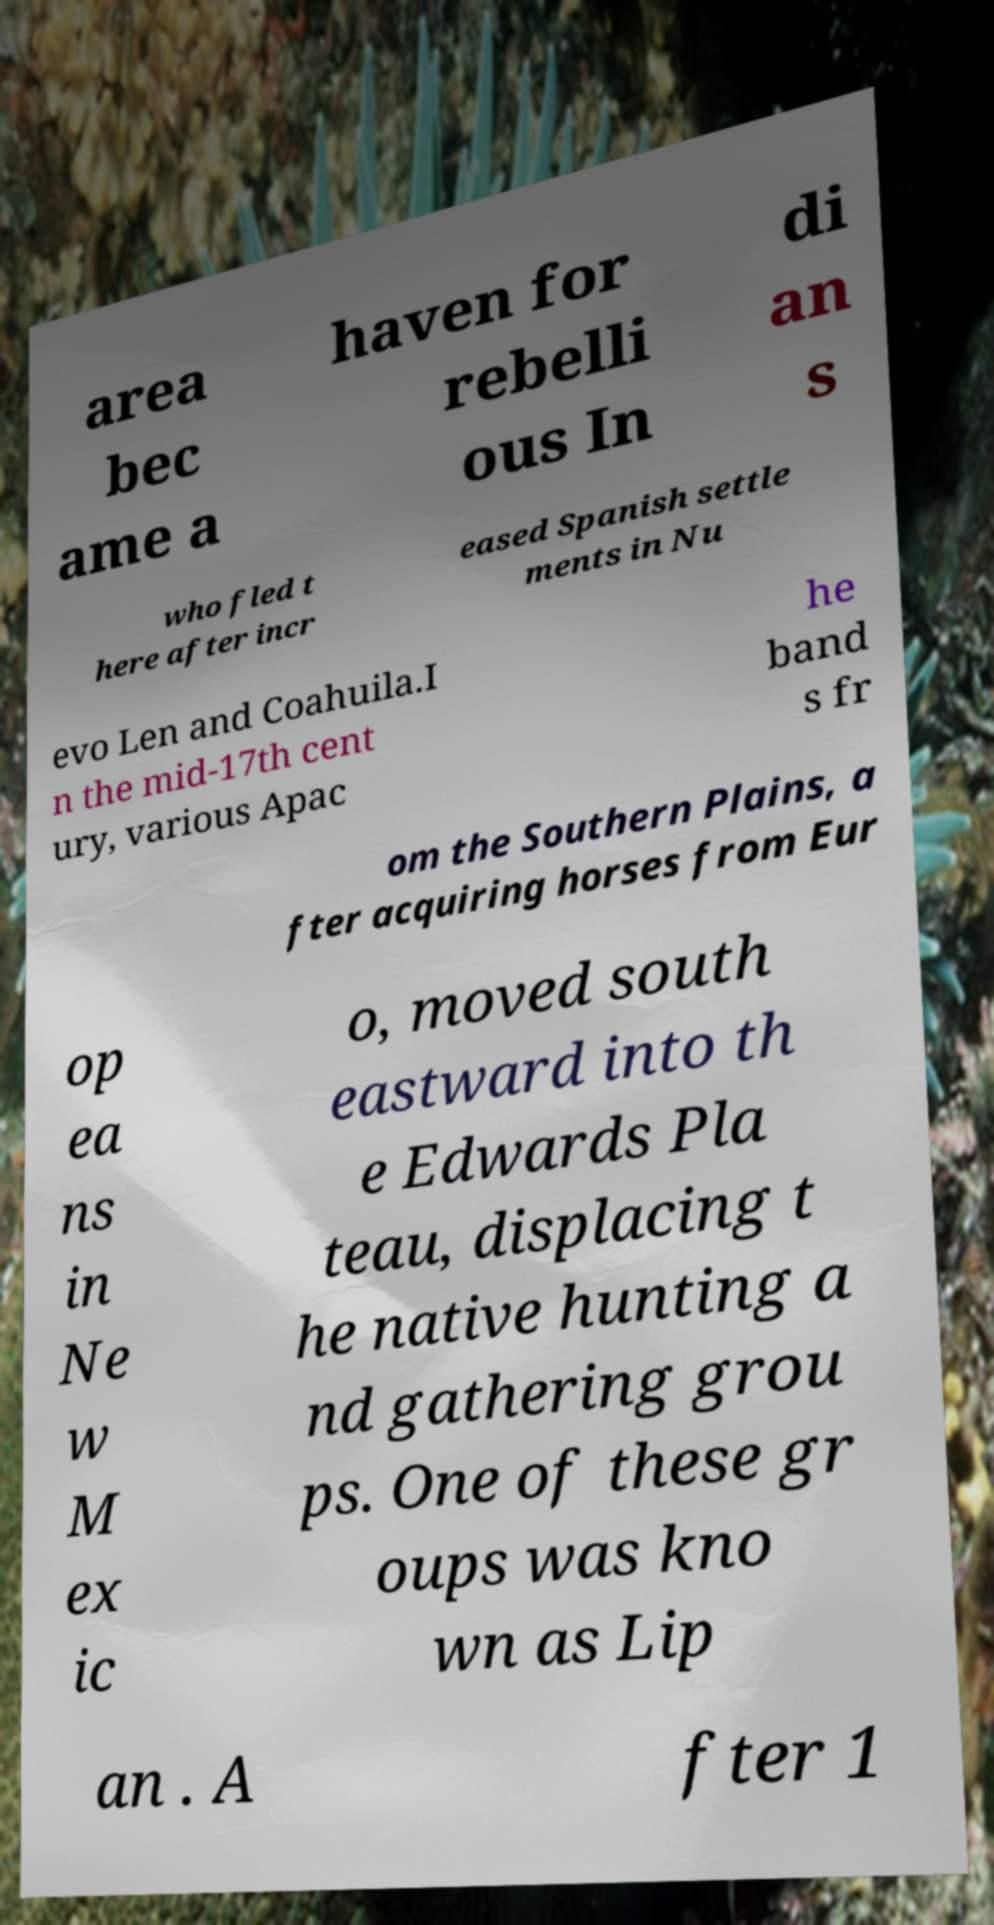I need the written content from this picture converted into text. Can you do that? area bec ame a haven for rebelli ous In di an s who fled t here after incr eased Spanish settle ments in Nu evo Len and Coahuila.I n the mid-17th cent ury, various Apac he band s fr om the Southern Plains, a fter acquiring horses from Eur op ea ns in Ne w M ex ic o, moved south eastward into th e Edwards Pla teau, displacing t he native hunting a nd gathering grou ps. One of these gr oups was kno wn as Lip an . A fter 1 